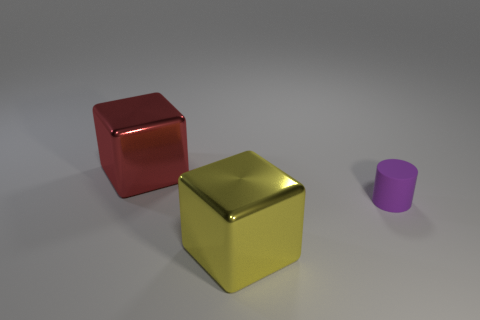Do the shiny object that is behind the matte cylinder and the object that is on the right side of the big yellow block have the same size?
Your answer should be very brief. No. What number of big metal things are the same color as the rubber cylinder?
Your answer should be very brief. 0. How many small things are either yellow cubes or red cubes?
Provide a succinct answer. 0. Is the large red block that is on the left side of the tiny purple thing made of the same material as the purple cylinder?
Your response must be concise. No. There is a metal cube that is behind the cylinder; what color is it?
Offer a very short reply. Red. Are there any other matte cylinders of the same size as the purple cylinder?
Your response must be concise. No. What material is the block that is the same size as the red thing?
Your answer should be very brief. Metal. There is a rubber thing; is it the same size as the cube that is in front of the big red cube?
Ensure brevity in your answer.  No. There is a cube that is right of the big red block; what is it made of?
Your answer should be compact. Metal. Is the number of red objects that are left of the red cube the same as the number of yellow things?
Make the answer very short. No. 